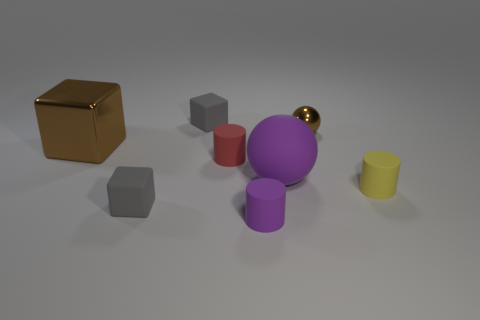Subtract all small purple cylinders. How many cylinders are left? 2 Add 1 small brown shiny spheres. How many objects exist? 9 Subtract 2 blocks. How many blocks are left? 1 Subtract all purple cylinders. How many cylinders are left? 2 Subtract all cylinders. How many objects are left? 5 Add 7 blue blocks. How many blue blocks exist? 7 Subtract 0 yellow cubes. How many objects are left? 8 Subtract all blue balls. Subtract all blue blocks. How many balls are left? 2 Subtract all red balls. How many gray cylinders are left? 0 Subtract all gray metallic objects. Subtract all tiny spheres. How many objects are left? 7 